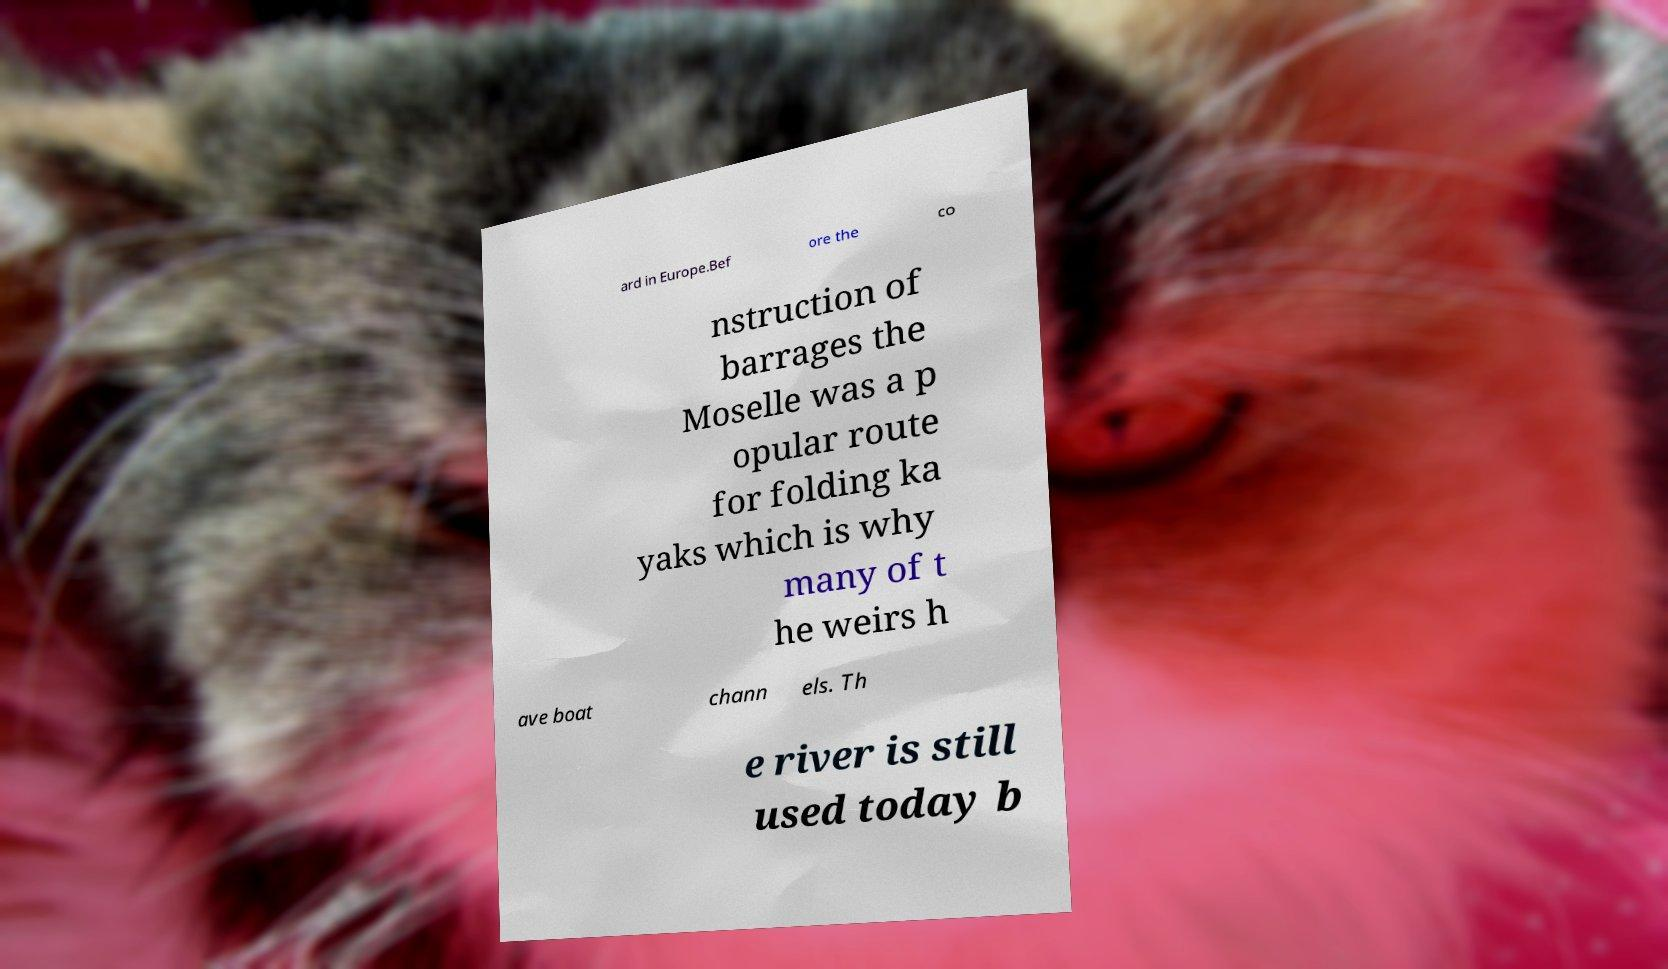Could you assist in decoding the text presented in this image and type it out clearly? ard in Europe.Bef ore the co nstruction of barrages the Moselle was a p opular route for folding ka yaks which is why many of t he weirs h ave boat chann els. Th e river is still used today b 